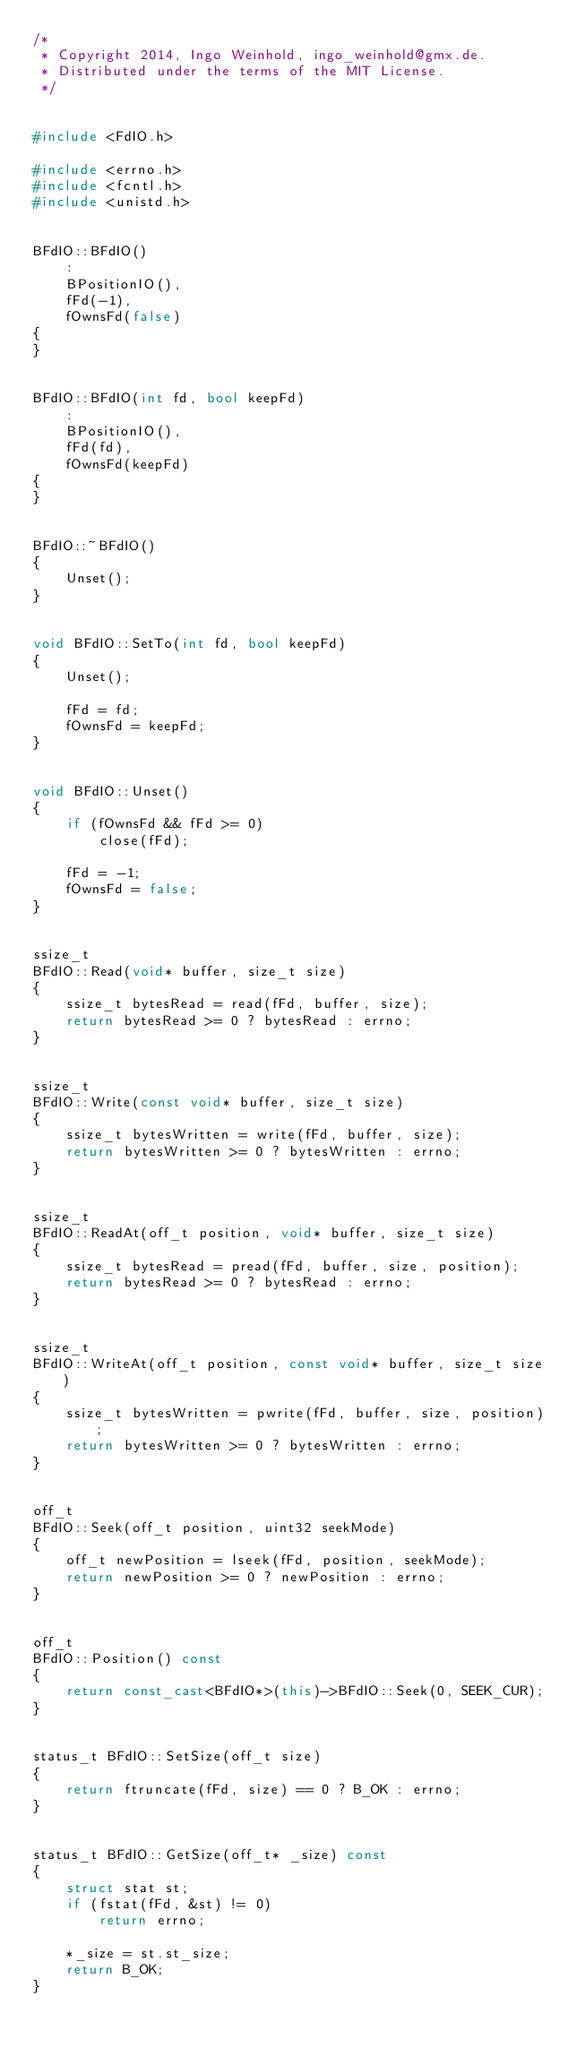<code> <loc_0><loc_0><loc_500><loc_500><_C++_>/*
 * Copyright 2014, Ingo Weinhold, ingo_weinhold@gmx.de.
 * Distributed under the terms of the MIT License.
 */


#include <FdIO.h>

#include <errno.h>
#include <fcntl.h>
#include <unistd.h>


BFdIO::BFdIO()
	:
	BPositionIO(),
	fFd(-1),
	fOwnsFd(false)
{
}


BFdIO::BFdIO(int fd, bool keepFd)
	:
	BPositionIO(),
	fFd(fd),
	fOwnsFd(keepFd)
{
}


BFdIO::~BFdIO()
{
	Unset();
}


void BFdIO::SetTo(int fd, bool keepFd)
{
	Unset();

	fFd = fd;
	fOwnsFd = keepFd;
}


void BFdIO::Unset()
{
	if (fOwnsFd && fFd >= 0)
		close(fFd);

	fFd = -1;
	fOwnsFd = false;
}


ssize_t
BFdIO::Read(void* buffer, size_t size)
{
	ssize_t bytesRead = read(fFd, buffer, size);
	return bytesRead >= 0 ? bytesRead : errno;
}


ssize_t
BFdIO::Write(const void* buffer, size_t size)
{
	ssize_t bytesWritten = write(fFd, buffer, size);
	return bytesWritten >= 0 ? bytesWritten : errno;
}


ssize_t
BFdIO::ReadAt(off_t position, void* buffer, size_t size)
{
	ssize_t bytesRead = pread(fFd, buffer, size, position);
	return bytesRead >= 0 ? bytesRead : errno;
}


ssize_t
BFdIO::WriteAt(off_t position, const void* buffer, size_t size)
{
	ssize_t bytesWritten = pwrite(fFd, buffer, size, position);
	return bytesWritten >= 0 ? bytesWritten : errno;
}


off_t
BFdIO::Seek(off_t position, uint32 seekMode)
{
	off_t newPosition = lseek(fFd, position, seekMode);
	return newPosition >= 0 ? newPosition : errno;
}


off_t
BFdIO::Position() const
{
	return const_cast<BFdIO*>(this)->BFdIO::Seek(0, SEEK_CUR);
}


status_t BFdIO::SetSize(off_t size)
{
	return ftruncate(fFd, size) == 0 ? B_OK : errno;
}


status_t BFdIO::GetSize(off_t* _size) const
{
	struct stat st;
	if (fstat(fFd, &st) != 0)
		return errno;

	*_size = st.st_size;
	return B_OK;
}
</code> 